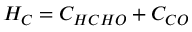<formula> <loc_0><loc_0><loc_500><loc_500>H _ { C } = C _ { H C H O } + C _ { C O }</formula> 